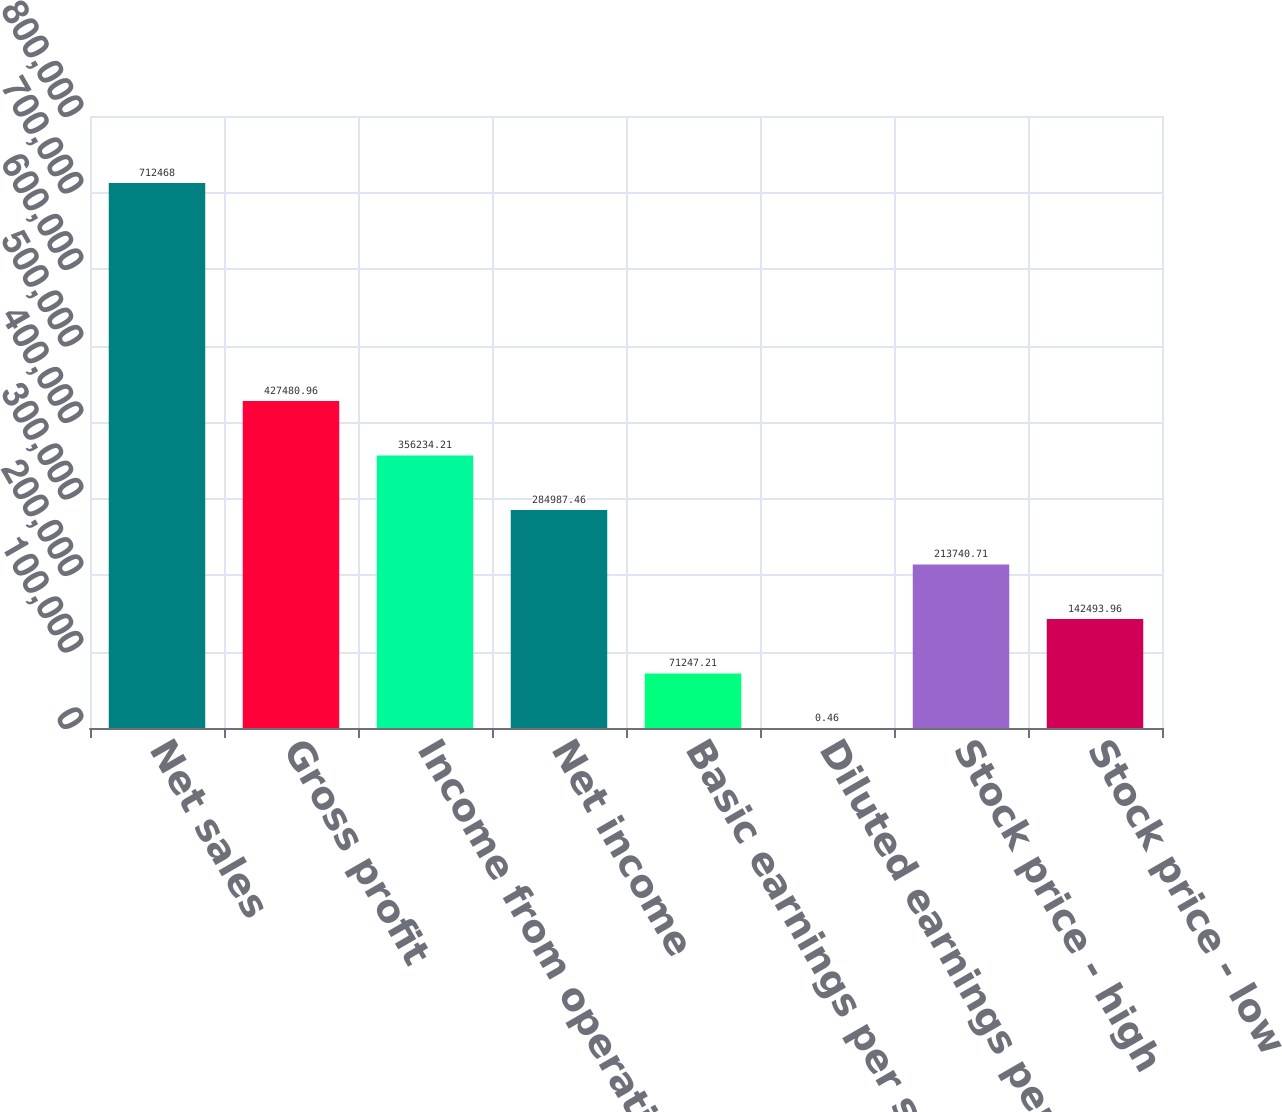Convert chart to OTSL. <chart><loc_0><loc_0><loc_500><loc_500><bar_chart><fcel>Net sales<fcel>Gross profit<fcel>Income from operations<fcel>Net income<fcel>Basic earnings per share<fcel>Diluted earnings per share<fcel>Stock price - high<fcel>Stock price - low<nl><fcel>712468<fcel>427481<fcel>356234<fcel>284987<fcel>71247.2<fcel>0.46<fcel>213741<fcel>142494<nl></chart> 